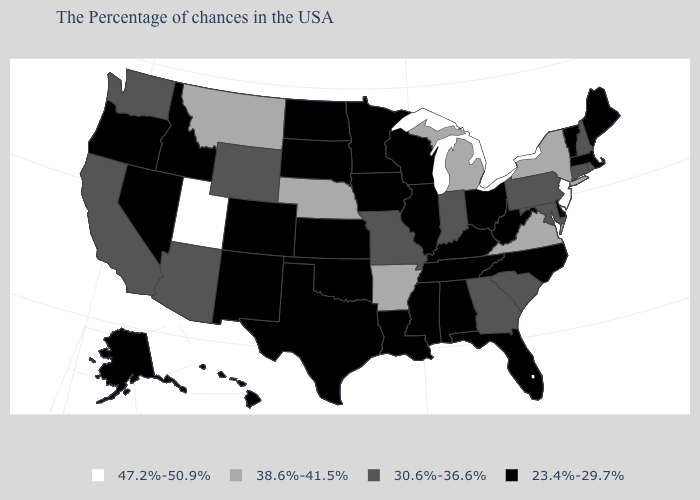What is the value of Maine?
Answer briefly. 23.4%-29.7%. What is the value of New Hampshire?
Be succinct. 30.6%-36.6%. Among the states that border Rhode Island , which have the highest value?
Answer briefly. Connecticut. Name the states that have a value in the range 30.6%-36.6%?
Quick response, please. Rhode Island, New Hampshire, Connecticut, Maryland, Pennsylvania, South Carolina, Georgia, Indiana, Missouri, Wyoming, Arizona, California, Washington. What is the highest value in the USA?
Write a very short answer. 47.2%-50.9%. What is the value of New Jersey?
Concise answer only. 47.2%-50.9%. Which states have the lowest value in the USA?
Give a very brief answer. Maine, Massachusetts, Vermont, Delaware, North Carolina, West Virginia, Ohio, Florida, Kentucky, Alabama, Tennessee, Wisconsin, Illinois, Mississippi, Louisiana, Minnesota, Iowa, Kansas, Oklahoma, Texas, South Dakota, North Dakota, Colorado, New Mexico, Idaho, Nevada, Oregon, Alaska, Hawaii. Name the states that have a value in the range 38.6%-41.5%?
Concise answer only. New York, Virginia, Michigan, Arkansas, Nebraska, Montana. Name the states that have a value in the range 30.6%-36.6%?
Keep it brief. Rhode Island, New Hampshire, Connecticut, Maryland, Pennsylvania, South Carolina, Georgia, Indiana, Missouri, Wyoming, Arizona, California, Washington. Name the states that have a value in the range 23.4%-29.7%?
Quick response, please. Maine, Massachusetts, Vermont, Delaware, North Carolina, West Virginia, Ohio, Florida, Kentucky, Alabama, Tennessee, Wisconsin, Illinois, Mississippi, Louisiana, Minnesota, Iowa, Kansas, Oklahoma, Texas, South Dakota, North Dakota, Colorado, New Mexico, Idaho, Nevada, Oregon, Alaska, Hawaii. Does Nevada have a lower value than Illinois?
Write a very short answer. No. Does New Jersey have the lowest value in the USA?
Give a very brief answer. No. Name the states that have a value in the range 30.6%-36.6%?
Keep it brief. Rhode Island, New Hampshire, Connecticut, Maryland, Pennsylvania, South Carolina, Georgia, Indiana, Missouri, Wyoming, Arizona, California, Washington. Among the states that border Michigan , which have the lowest value?
Write a very short answer. Ohio, Wisconsin. What is the value of Virginia?
Short answer required. 38.6%-41.5%. 